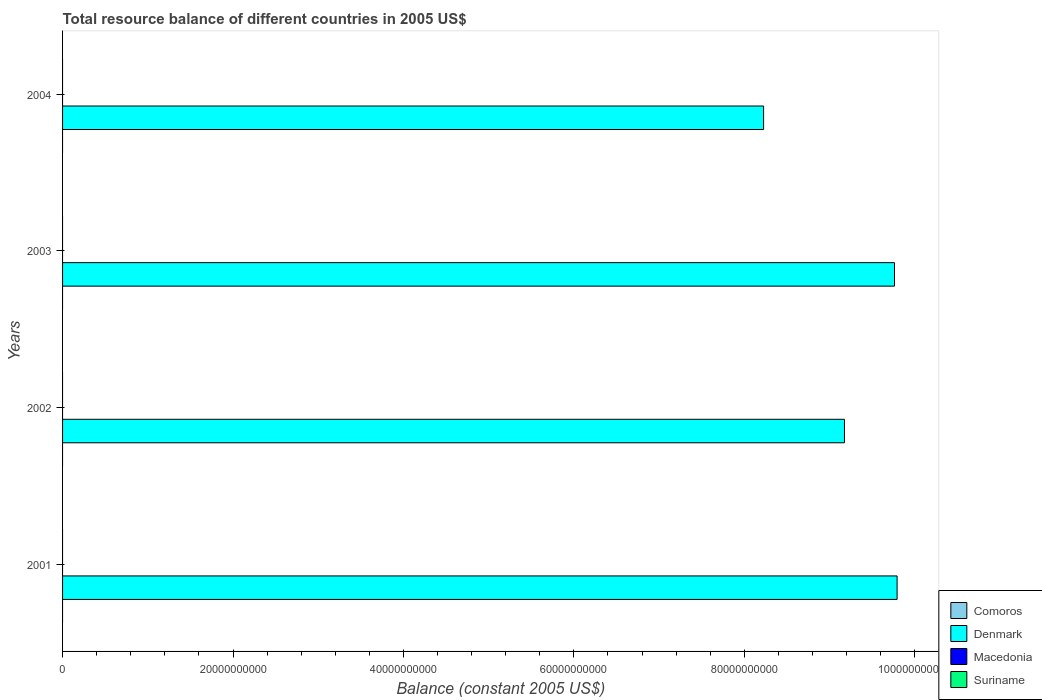Are the number of bars on each tick of the Y-axis equal?
Provide a short and direct response. Yes. In how many cases, is the number of bars for a given year not equal to the number of legend labels?
Offer a very short reply. 4. Across all years, what is the maximum total resource balance in Denmark?
Your answer should be very brief. 9.79e+1. In which year was the total resource balance in Denmark maximum?
Offer a very short reply. 2001. What is the total total resource balance in Comoros in the graph?
Make the answer very short. 0. What is the difference between the total resource balance in Denmark in 2001 and that in 2002?
Your answer should be very brief. 6.18e+09. What is the average total resource balance in Denmark per year?
Your answer should be very brief. 9.24e+1. What is the ratio of the total resource balance in Denmark in 2001 to that in 2004?
Give a very brief answer. 1.19. What is the difference between the highest and the lowest total resource balance in Denmark?
Provide a succinct answer. 1.57e+1. Is the sum of the total resource balance in Denmark in 2002 and 2003 greater than the maximum total resource balance in Suriname across all years?
Give a very brief answer. Yes. Is it the case that in every year, the sum of the total resource balance in Denmark and total resource balance in Comoros is greater than the total resource balance in Macedonia?
Give a very brief answer. Yes. How many bars are there?
Offer a very short reply. 4. Are all the bars in the graph horizontal?
Provide a short and direct response. Yes. How many years are there in the graph?
Ensure brevity in your answer.  4. What is the difference between two consecutive major ticks on the X-axis?
Offer a terse response. 2.00e+1. Are the values on the major ticks of X-axis written in scientific E-notation?
Offer a terse response. No. Does the graph contain grids?
Provide a short and direct response. No. Where does the legend appear in the graph?
Your answer should be very brief. Bottom right. How are the legend labels stacked?
Your response must be concise. Vertical. What is the title of the graph?
Keep it short and to the point. Total resource balance of different countries in 2005 US$. What is the label or title of the X-axis?
Make the answer very short. Balance (constant 2005 US$). What is the Balance (constant 2005 US$) in Comoros in 2001?
Give a very brief answer. 0. What is the Balance (constant 2005 US$) of Denmark in 2001?
Provide a succinct answer. 9.79e+1. What is the Balance (constant 2005 US$) in Suriname in 2001?
Provide a succinct answer. 0. What is the Balance (constant 2005 US$) of Denmark in 2002?
Offer a terse response. 9.18e+1. What is the Balance (constant 2005 US$) in Macedonia in 2002?
Give a very brief answer. 0. What is the Balance (constant 2005 US$) in Denmark in 2003?
Your answer should be very brief. 9.76e+1. What is the Balance (constant 2005 US$) of Macedonia in 2003?
Give a very brief answer. 0. What is the Balance (constant 2005 US$) of Suriname in 2003?
Your answer should be compact. 0. What is the Balance (constant 2005 US$) in Denmark in 2004?
Make the answer very short. 8.23e+1. What is the Balance (constant 2005 US$) of Macedonia in 2004?
Keep it short and to the point. 0. Across all years, what is the maximum Balance (constant 2005 US$) in Denmark?
Your answer should be compact. 9.79e+1. Across all years, what is the minimum Balance (constant 2005 US$) in Denmark?
Make the answer very short. 8.23e+1. What is the total Balance (constant 2005 US$) of Comoros in the graph?
Keep it short and to the point. 0. What is the total Balance (constant 2005 US$) of Denmark in the graph?
Ensure brevity in your answer.  3.70e+11. What is the total Balance (constant 2005 US$) in Macedonia in the graph?
Give a very brief answer. 0. What is the total Balance (constant 2005 US$) of Suriname in the graph?
Ensure brevity in your answer.  0. What is the difference between the Balance (constant 2005 US$) of Denmark in 2001 and that in 2002?
Your answer should be compact. 6.18e+09. What is the difference between the Balance (constant 2005 US$) of Denmark in 2001 and that in 2003?
Provide a short and direct response. 3.04e+08. What is the difference between the Balance (constant 2005 US$) in Denmark in 2001 and that in 2004?
Keep it short and to the point. 1.57e+1. What is the difference between the Balance (constant 2005 US$) in Denmark in 2002 and that in 2003?
Your answer should be compact. -5.87e+09. What is the difference between the Balance (constant 2005 US$) in Denmark in 2002 and that in 2004?
Make the answer very short. 9.49e+09. What is the difference between the Balance (constant 2005 US$) in Denmark in 2003 and that in 2004?
Ensure brevity in your answer.  1.54e+1. What is the average Balance (constant 2005 US$) of Comoros per year?
Your answer should be very brief. 0. What is the average Balance (constant 2005 US$) in Denmark per year?
Keep it short and to the point. 9.24e+1. What is the average Balance (constant 2005 US$) of Macedonia per year?
Your response must be concise. 0. What is the average Balance (constant 2005 US$) of Suriname per year?
Ensure brevity in your answer.  0. What is the ratio of the Balance (constant 2005 US$) of Denmark in 2001 to that in 2002?
Offer a terse response. 1.07. What is the ratio of the Balance (constant 2005 US$) of Denmark in 2001 to that in 2004?
Make the answer very short. 1.19. What is the ratio of the Balance (constant 2005 US$) of Denmark in 2002 to that in 2003?
Ensure brevity in your answer.  0.94. What is the ratio of the Balance (constant 2005 US$) in Denmark in 2002 to that in 2004?
Make the answer very short. 1.12. What is the ratio of the Balance (constant 2005 US$) in Denmark in 2003 to that in 2004?
Your answer should be compact. 1.19. What is the difference between the highest and the second highest Balance (constant 2005 US$) of Denmark?
Keep it short and to the point. 3.04e+08. What is the difference between the highest and the lowest Balance (constant 2005 US$) in Denmark?
Give a very brief answer. 1.57e+1. 